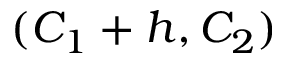Convert formula to latex. <formula><loc_0><loc_0><loc_500><loc_500>( C _ { 1 } + h , C _ { 2 } )</formula> 